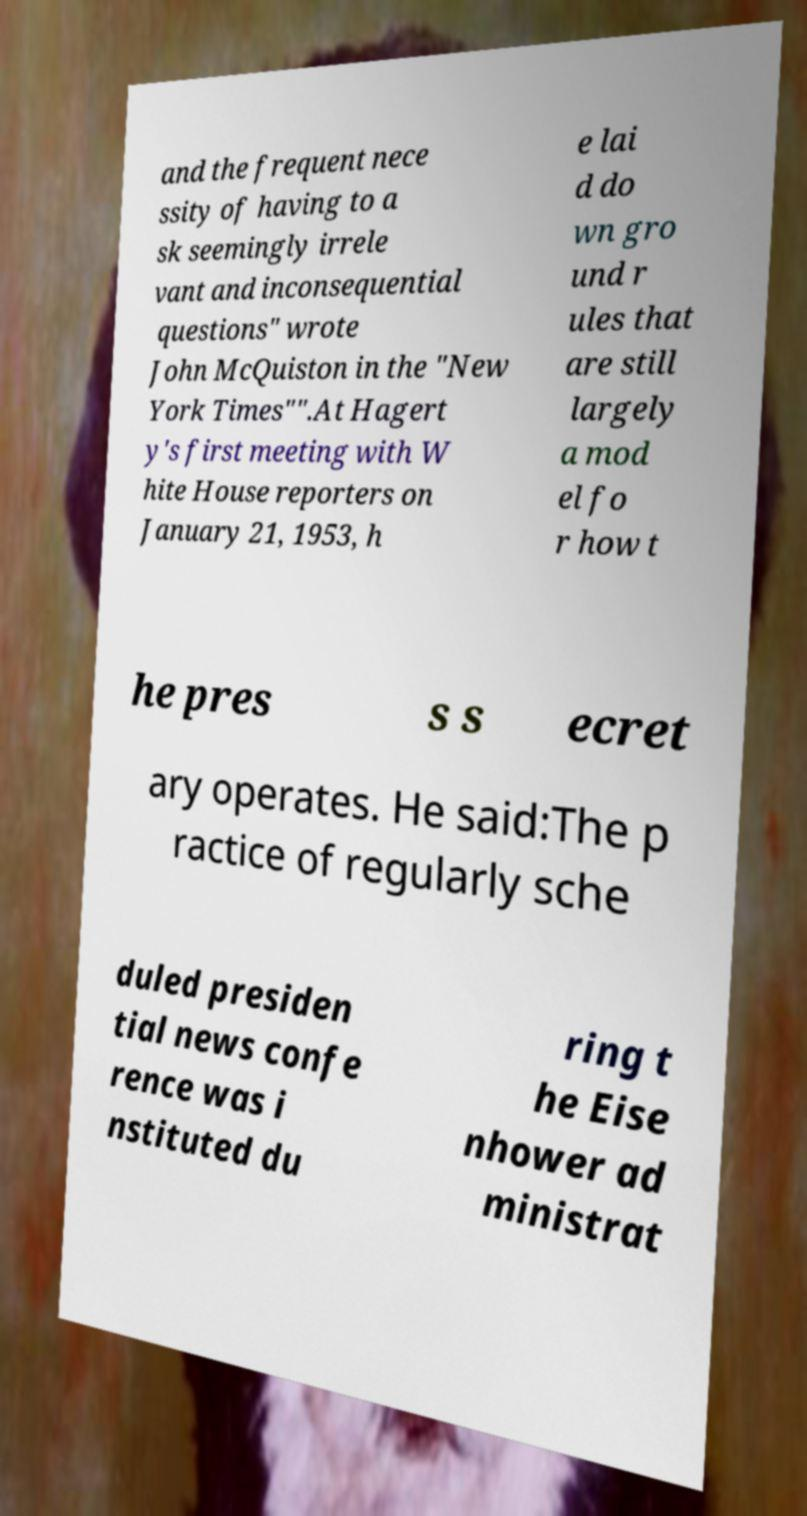For documentation purposes, I need the text within this image transcribed. Could you provide that? and the frequent nece ssity of having to a sk seemingly irrele vant and inconsequential questions" wrote John McQuiston in the "New York Times"".At Hagert y's first meeting with W hite House reporters on January 21, 1953, h e lai d do wn gro und r ules that are still largely a mod el fo r how t he pres s s ecret ary operates. He said:The p ractice of regularly sche duled presiden tial news confe rence was i nstituted du ring t he Eise nhower ad ministrat 